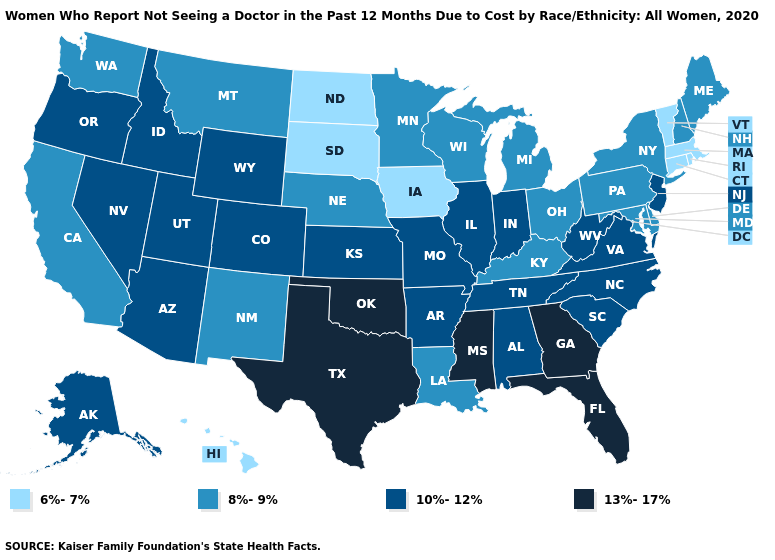Name the states that have a value in the range 13%-17%?
Concise answer only. Florida, Georgia, Mississippi, Oklahoma, Texas. Does Florida have the highest value in the South?
Write a very short answer. Yes. How many symbols are there in the legend?
Concise answer only. 4. Name the states that have a value in the range 10%-12%?
Write a very short answer. Alabama, Alaska, Arizona, Arkansas, Colorado, Idaho, Illinois, Indiana, Kansas, Missouri, Nevada, New Jersey, North Carolina, Oregon, South Carolina, Tennessee, Utah, Virginia, West Virginia, Wyoming. What is the value of Michigan?
Short answer required. 8%-9%. Name the states that have a value in the range 13%-17%?
Answer briefly. Florida, Georgia, Mississippi, Oklahoma, Texas. Among the states that border Pennsylvania , which have the highest value?
Concise answer only. New Jersey, West Virginia. Does Indiana have the highest value in the USA?
Be succinct. No. Name the states that have a value in the range 10%-12%?
Short answer required. Alabama, Alaska, Arizona, Arkansas, Colorado, Idaho, Illinois, Indiana, Kansas, Missouri, Nevada, New Jersey, North Carolina, Oregon, South Carolina, Tennessee, Utah, Virginia, West Virginia, Wyoming. Which states hav the highest value in the Northeast?
Quick response, please. New Jersey. What is the highest value in the USA?
Quick response, please. 13%-17%. What is the highest value in the West ?
Quick response, please. 10%-12%. Does New Jersey have a lower value than Louisiana?
Be succinct. No. Name the states that have a value in the range 6%-7%?
Be succinct. Connecticut, Hawaii, Iowa, Massachusetts, North Dakota, Rhode Island, South Dakota, Vermont. 